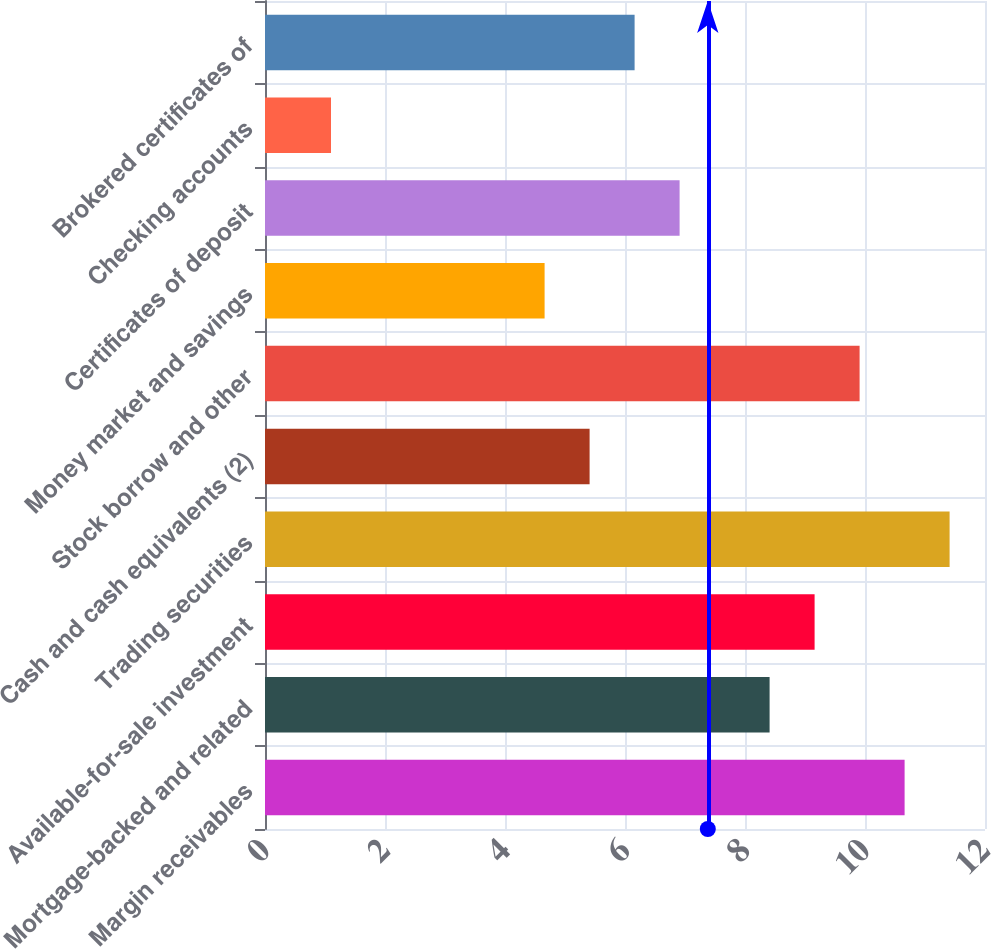Convert chart. <chart><loc_0><loc_0><loc_500><loc_500><bar_chart><fcel>Margin receivables<fcel>Mortgage-backed and related<fcel>Available-for-sale investment<fcel>Trading securities<fcel>Cash and cash equivalents (2)<fcel>Stock borrow and other<fcel>Money market and savings<fcel>Certificates of deposit<fcel>Checking accounts<fcel>Brokered certificates of<nl><fcel>10.66<fcel>8.41<fcel>9.16<fcel>11.41<fcel>5.41<fcel>9.91<fcel>4.66<fcel>6.91<fcel>1.1<fcel>6.16<nl></chart> 